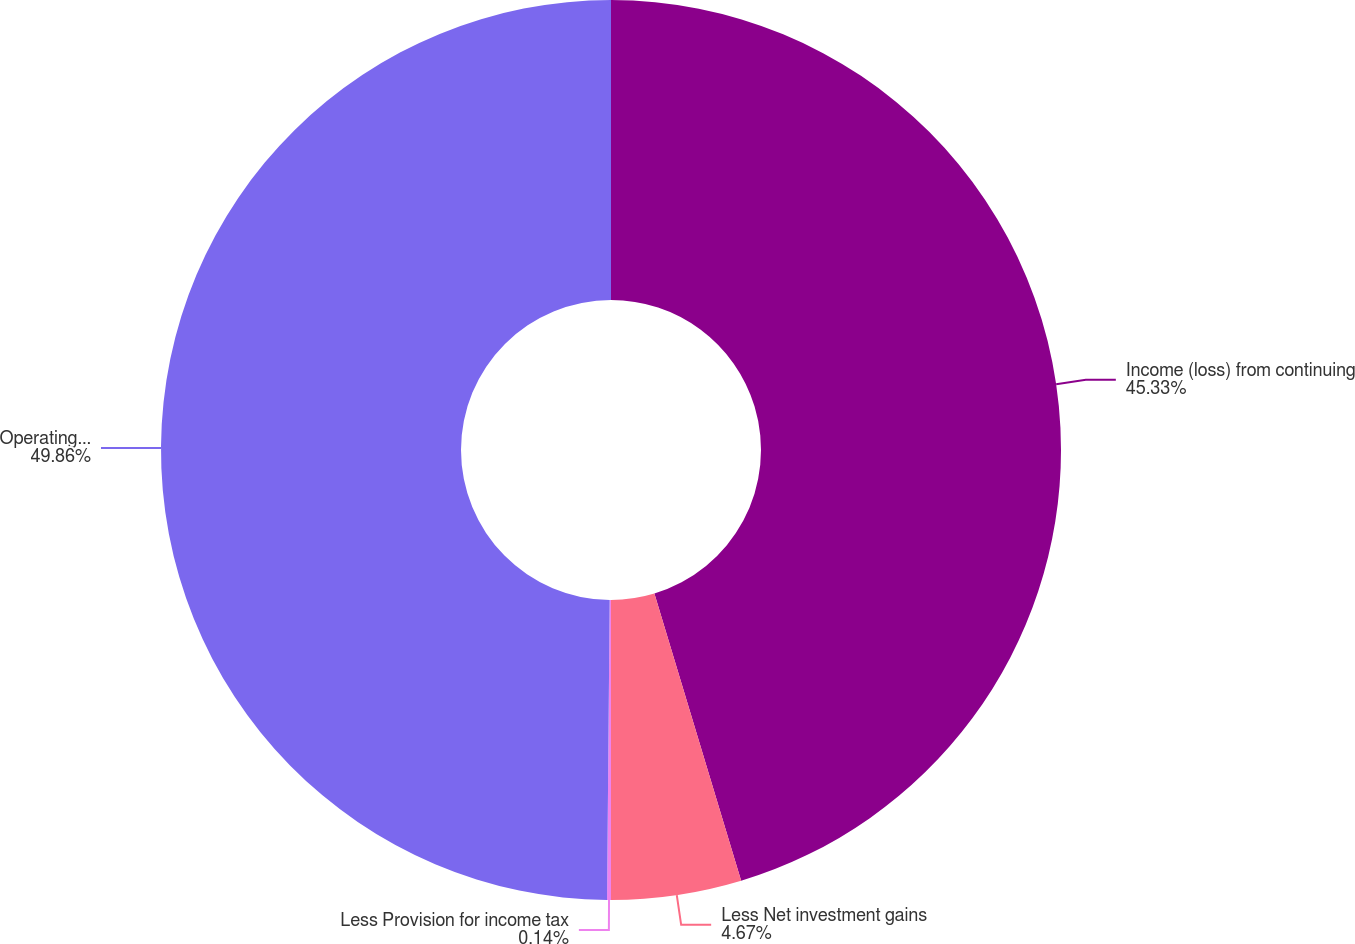Convert chart to OTSL. <chart><loc_0><loc_0><loc_500><loc_500><pie_chart><fcel>Income (loss) from continuing<fcel>Less Net investment gains<fcel>Less Provision for income tax<fcel>Operatingearnings<nl><fcel>45.33%<fcel>4.67%<fcel>0.14%<fcel>49.86%<nl></chart> 